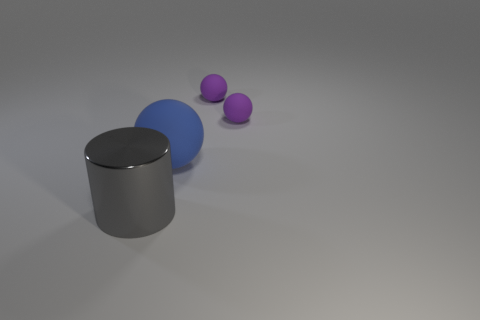Is there a sphere made of the same material as the big blue thing?
Ensure brevity in your answer.  Yes. Are there more purple cubes than large cylinders?
Offer a terse response. No. What color is the large object to the right of the object in front of the big thing behind the big gray object?
Give a very brief answer. Blue. Do the large object that is on the right side of the shiny cylinder and the large object in front of the big rubber sphere have the same color?
Keep it short and to the point. No. There is a big object that is in front of the big blue ball; what number of tiny rubber things are behind it?
Your response must be concise. 2. Are any small things visible?
Your answer should be compact. Yes. Are there fewer red cubes than large cylinders?
Ensure brevity in your answer.  Yes. What is the shape of the big thing that is in front of the large thing behind the big gray cylinder?
Your answer should be very brief. Cylinder. There is a big blue object; are there any spheres to the left of it?
Keep it short and to the point. No. There is a rubber sphere that is the same size as the shiny cylinder; what is its color?
Give a very brief answer. Blue. 